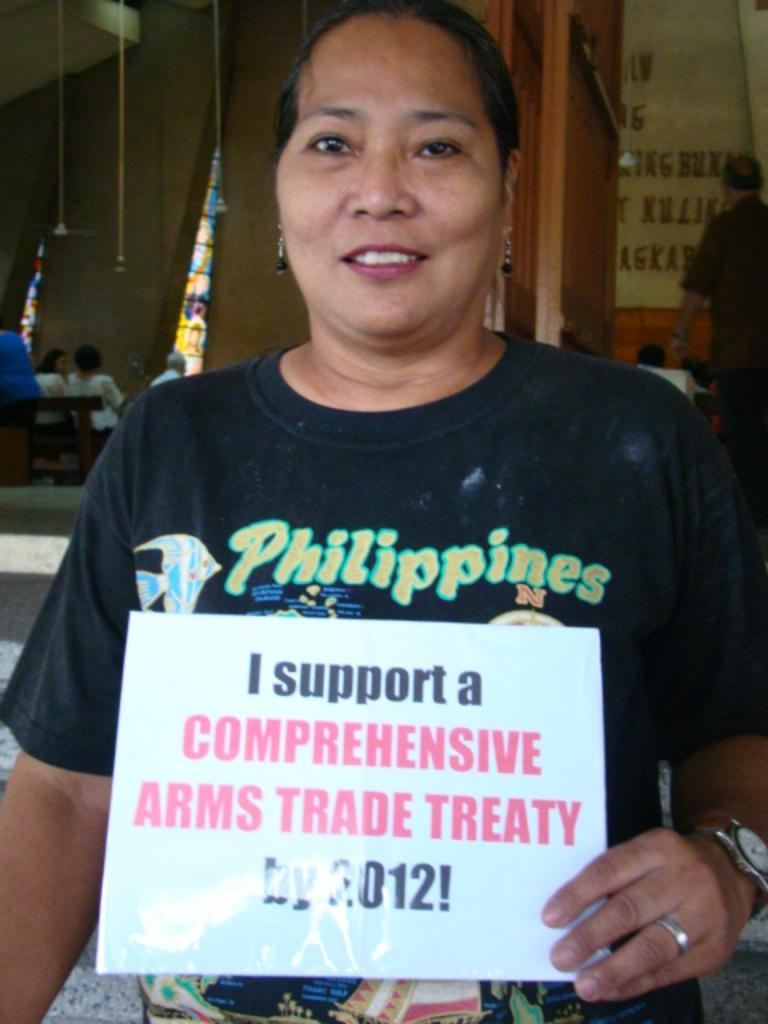What is the main subject of the image? There is a woman in the image. What is the woman doing in the image? The woman is standing and smiling. What is the woman holding in the image? The woman is holding a board. What can be seen in the background of the image? There are people sitting on a bench and people standing in the background, as well as lights visible. What type of liquid is the woman swimming in the image? There is no liquid or swimming activity present in the image; the woman is standing and holding a board. How many apples can be seen on the bench in the image? There are no apples present in the image; the bench contains people sitting. 